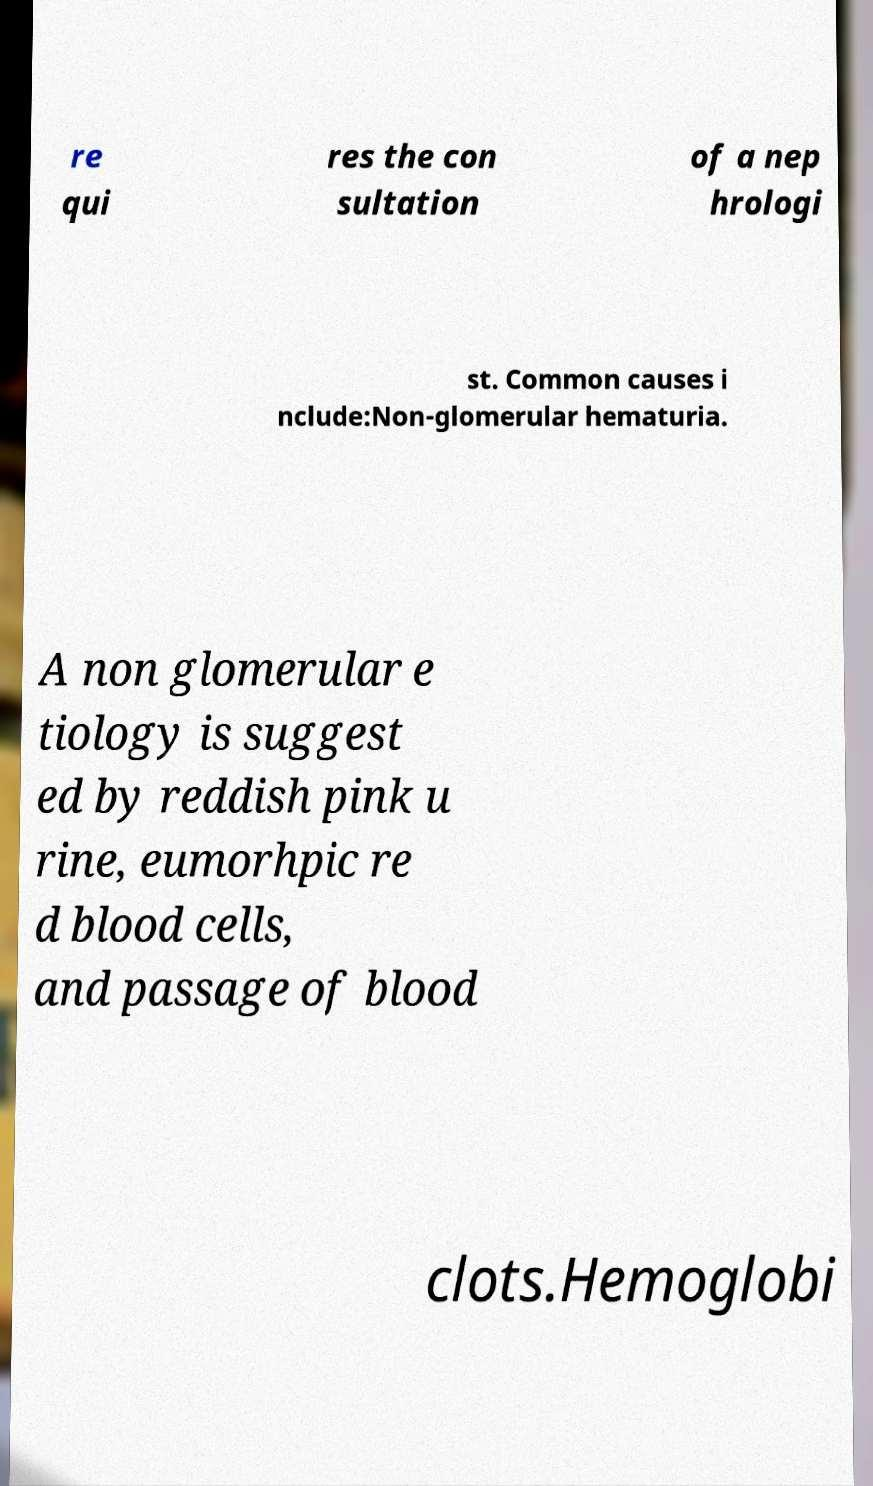What messages or text are displayed in this image? I need them in a readable, typed format. re qui res the con sultation of a nep hrologi st. Common causes i nclude:Non-glomerular hematuria. A non glomerular e tiology is suggest ed by reddish pink u rine, eumorhpic re d blood cells, and passage of blood clots.Hemoglobi 